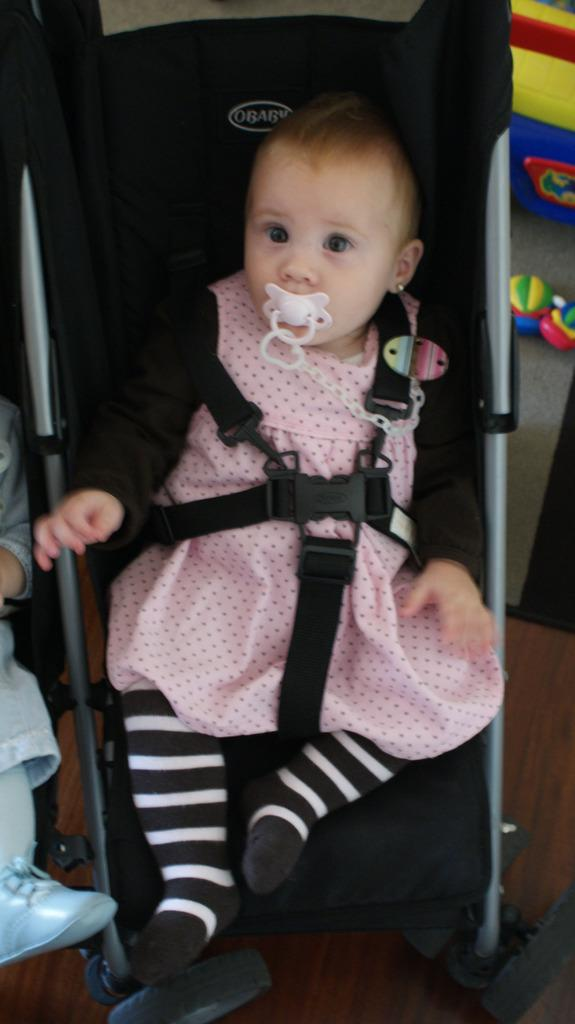What is the kid doing in the image? The kid is sitting on a stroller in the image. What is the kid holding or doing with their mouth? The kid has an object in their mouth. Who is present near the stroller? There is a person beside the stroller. What can be seen in the background of the image? There are toys visible in the background of the image. What is the ghost's opinion about the toys in the image? There is no ghost present in the image, so it is not possible to determine their opinion about the toys. 